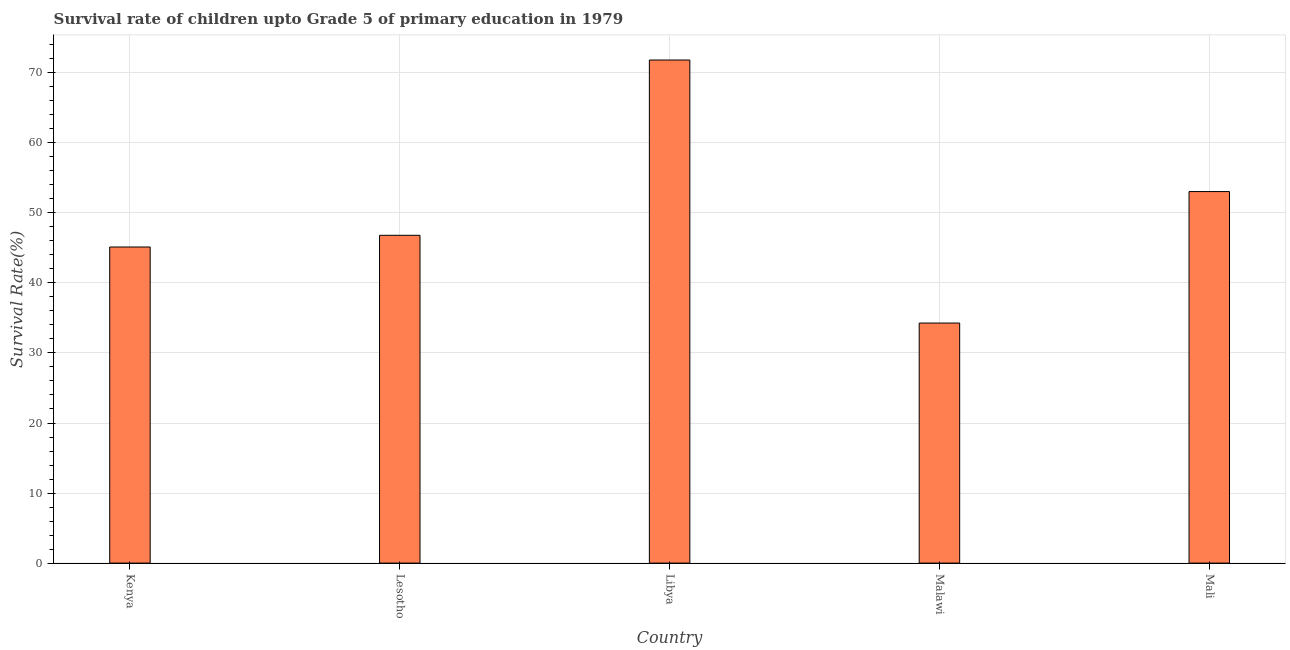Does the graph contain any zero values?
Keep it short and to the point. No. Does the graph contain grids?
Offer a terse response. Yes. What is the title of the graph?
Your answer should be very brief. Survival rate of children upto Grade 5 of primary education in 1979 . What is the label or title of the Y-axis?
Make the answer very short. Survival Rate(%). What is the survival rate in Mali?
Keep it short and to the point. 53.04. Across all countries, what is the maximum survival rate?
Offer a very short reply. 71.82. Across all countries, what is the minimum survival rate?
Keep it short and to the point. 34.27. In which country was the survival rate maximum?
Offer a terse response. Libya. In which country was the survival rate minimum?
Make the answer very short. Malawi. What is the sum of the survival rate?
Offer a terse response. 251.06. What is the difference between the survival rate in Libya and Mali?
Provide a succinct answer. 18.78. What is the average survival rate per country?
Ensure brevity in your answer.  50.21. What is the median survival rate?
Your answer should be compact. 46.8. In how many countries, is the survival rate greater than 64 %?
Offer a very short reply. 1. What is the ratio of the survival rate in Malawi to that in Mali?
Offer a very short reply. 0.65. Is the difference between the survival rate in Malawi and Mali greater than the difference between any two countries?
Offer a terse response. No. What is the difference between the highest and the second highest survival rate?
Provide a short and direct response. 18.78. What is the difference between the highest and the lowest survival rate?
Ensure brevity in your answer.  37.55. In how many countries, is the survival rate greater than the average survival rate taken over all countries?
Offer a terse response. 2. Are all the bars in the graph horizontal?
Make the answer very short. No. How many countries are there in the graph?
Ensure brevity in your answer.  5. Are the values on the major ticks of Y-axis written in scientific E-notation?
Provide a short and direct response. No. What is the Survival Rate(%) in Kenya?
Your answer should be very brief. 45.13. What is the Survival Rate(%) in Lesotho?
Give a very brief answer. 46.8. What is the Survival Rate(%) of Libya?
Make the answer very short. 71.82. What is the Survival Rate(%) of Malawi?
Make the answer very short. 34.27. What is the Survival Rate(%) of Mali?
Offer a very short reply. 53.04. What is the difference between the Survival Rate(%) in Kenya and Lesotho?
Ensure brevity in your answer.  -1.67. What is the difference between the Survival Rate(%) in Kenya and Libya?
Keep it short and to the point. -26.69. What is the difference between the Survival Rate(%) in Kenya and Malawi?
Ensure brevity in your answer.  10.86. What is the difference between the Survival Rate(%) in Kenya and Mali?
Keep it short and to the point. -7.91. What is the difference between the Survival Rate(%) in Lesotho and Libya?
Keep it short and to the point. -25.02. What is the difference between the Survival Rate(%) in Lesotho and Malawi?
Offer a terse response. 12.53. What is the difference between the Survival Rate(%) in Lesotho and Mali?
Your response must be concise. -6.24. What is the difference between the Survival Rate(%) in Libya and Malawi?
Provide a short and direct response. 37.55. What is the difference between the Survival Rate(%) in Libya and Mali?
Make the answer very short. 18.78. What is the difference between the Survival Rate(%) in Malawi and Mali?
Ensure brevity in your answer.  -18.77. What is the ratio of the Survival Rate(%) in Kenya to that in Libya?
Provide a short and direct response. 0.63. What is the ratio of the Survival Rate(%) in Kenya to that in Malawi?
Your answer should be very brief. 1.32. What is the ratio of the Survival Rate(%) in Kenya to that in Mali?
Offer a very short reply. 0.85. What is the ratio of the Survival Rate(%) in Lesotho to that in Libya?
Your answer should be very brief. 0.65. What is the ratio of the Survival Rate(%) in Lesotho to that in Malawi?
Offer a terse response. 1.37. What is the ratio of the Survival Rate(%) in Lesotho to that in Mali?
Your answer should be compact. 0.88. What is the ratio of the Survival Rate(%) in Libya to that in Malawi?
Provide a succinct answer. 2.1. What is the ratio of the Survival Rate(%) in Libya to that in Mali?
Offer a very short reply. 1.35. What is the ratio of the Survival Rate(%) in Malawi to that in Mali?
Make the answer very short. 0.65. 